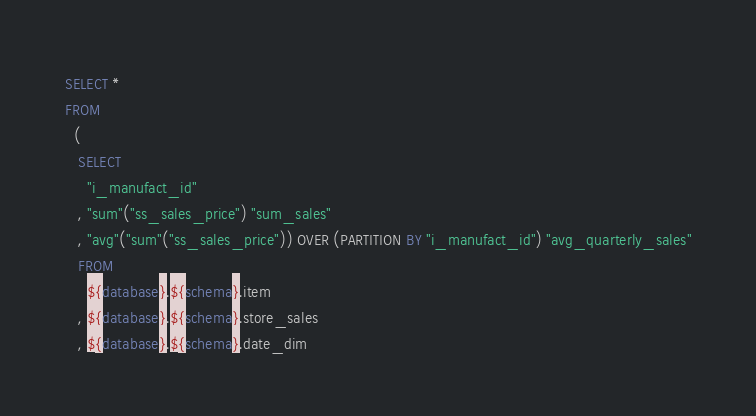Convert code to text. <code><loc_0><loc_0><loc_500><loc_500><_SQL_>SELECT *
FROM
  (
   SELECT
     "i_manufact_id"
   , "sum"("ss_sales_price") "sum_sales"
   , "avg"("sum"("ss_sales_price")) OVER (PARTITION BY "i_manufact_id") "avg_quarterly_sales"
   FROM
     ${database}.${schema}.item
   , ${database}.${schema}.store_sales
   , ${database}.${schema}.date_dim</code> 